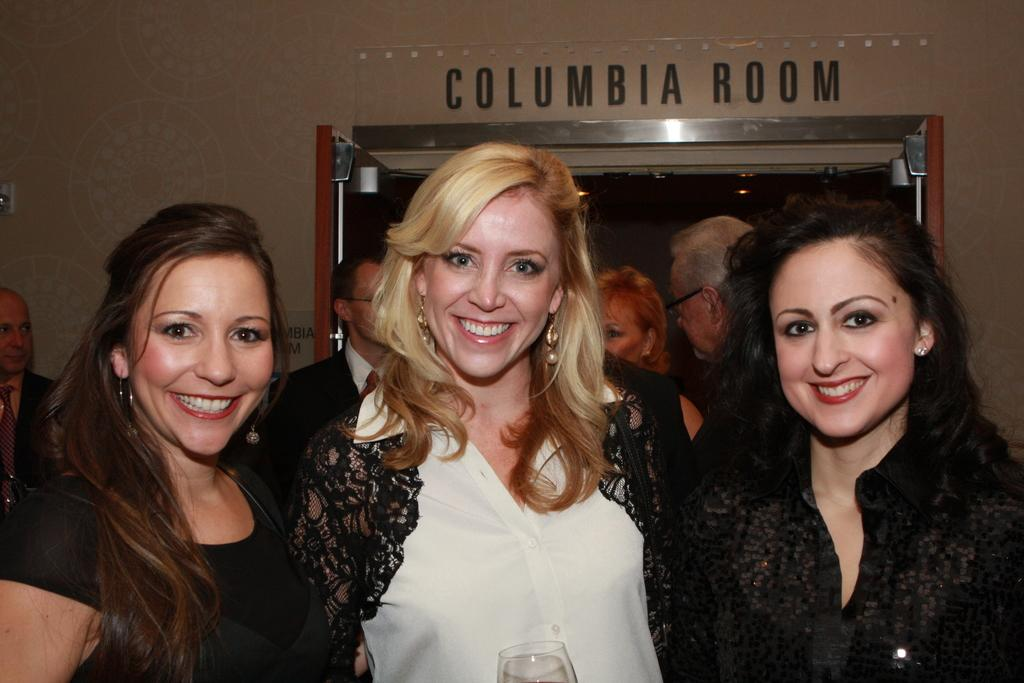What is the primary subject of the image? There is a woman in the image. Can you describe the woman's expression? The woman is smiling. What is the woman wearing? The woman is wearing a white dress. Are there any other people in the image? Yes, there is another woman in the image. What is the second woman wearing? The second woman is wearing a black dress. What type of coil can be seen in the image? There is no coil present in the image. What sound does the bell make in the image? There is no bell present in the image. 